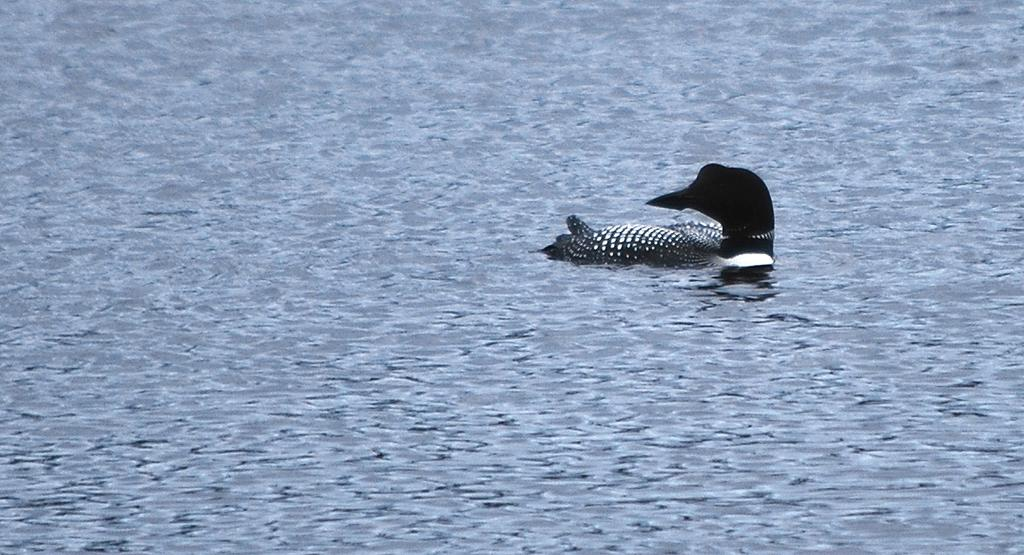What type of animal can be seen in the image? There is a bird in the image. Where is the bird located in the image? The bird is in the water. What type of silver object can be seen in the image? There is no silver object present in the image; it features a bird in the water. How many yards of fabric are visible in the image? There is no fabric or measurement of fabric in the image. 